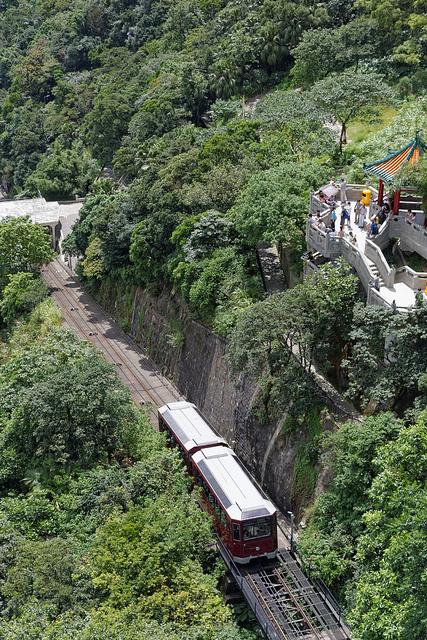How many people are in this photo?
Keep it brief. 0. Is this train in the desert?
Give a very brief answer. No. How many cars are on this train?
Answer briefly. 2. How many train cars are there?
Answer briefly. 2. 